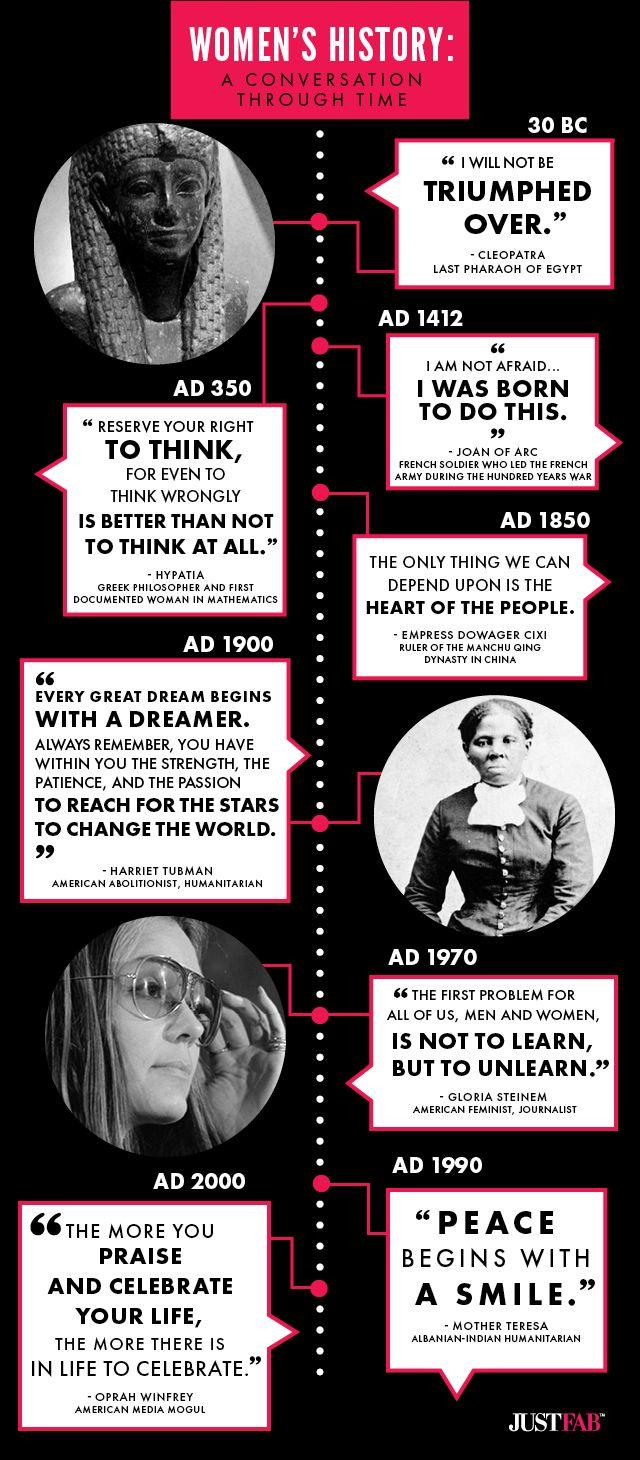Highlight a few significant elements in this photo. Joan of Arc was born in the 15th century. Harriet Tubman and Mother Teresa were humanitarians in the 20th century. 